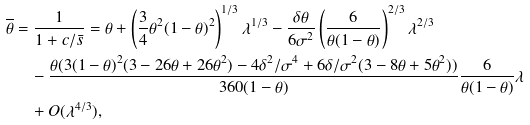Convert formula to latex. <formula><loc_0><loc_0><loc_500><loc_500>\overline { \theta } & = \frac { 1 } { 1 + c / \bar { s } } = \theta + \left ( \frac { 3 } { 4 } \theta ^ { 2 } ( 1 - \theta ) ^ { 2 } \right ) ^ { 1 / 3 } \lambda ^ { 1 / 3 } - \frac { \delta \theta } { 6 \sigma ^ { 2 } } \left ( \frac { 6 } { \theta ( 1 - \theta ) } \right ) ^ { 2 / 3 } \lambda ^ { 2 / 3 } \\ & \quad - \frac { \theta ( 3 ( 1 - \theta ) ^ { 2 } ( 3 - 2 6 \theta + 2 6 \theta ^ { 2 } ) - 4 \delta ^ { 2 } / \sigma ^ { 4 } + 6 \delta / \sigma ^ { 2 } ( 3 - 8 \theta + 5 \theta ^ { 2 } ) ) } { 3 6 0 ( 1 - \theta ) } \frac { 6 } { \theta ( 1 - \theta ) } \lambda \\ & \quad + O ( \lambda ^ { 4 / 3 } ) ,</formula> 